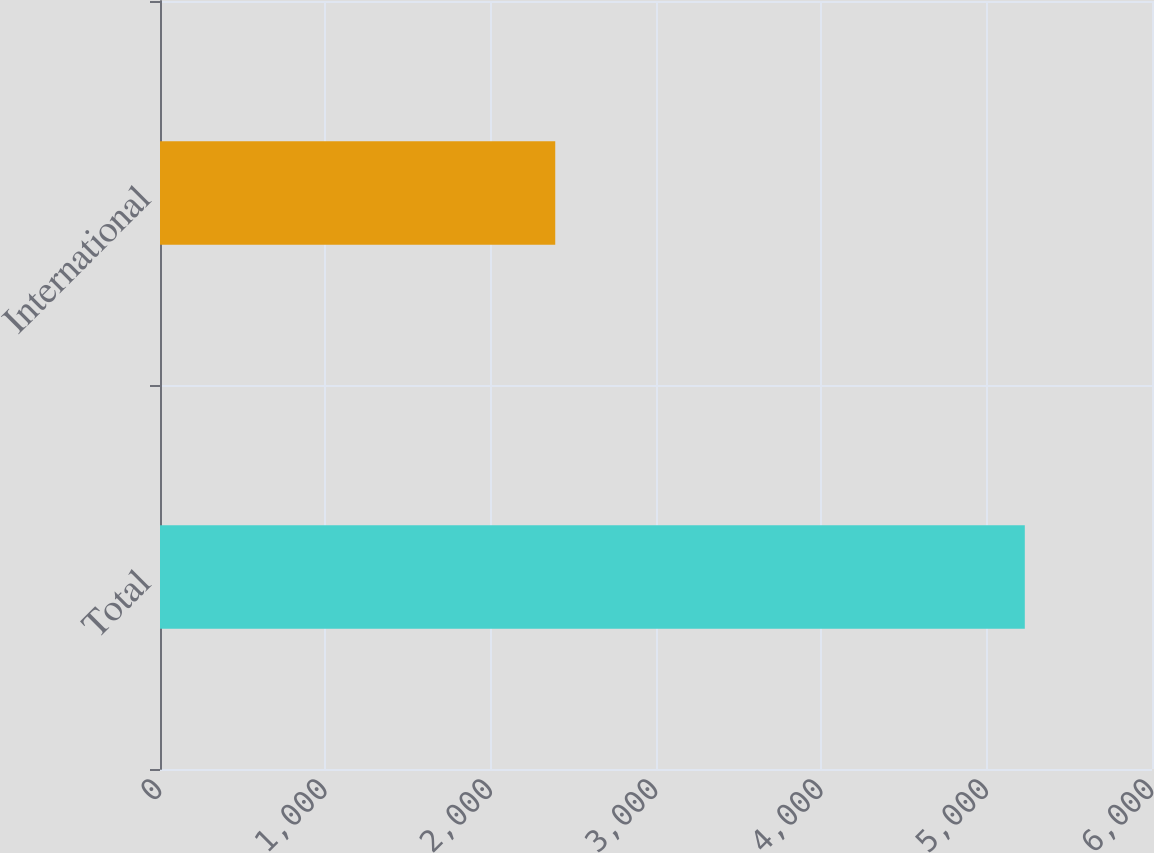Convert chart to OTSL. <chart><loc_0><loc_0><loc_500><loc_500><bar_chart><fcel>Total<fcel>International<nl><fcel>5230.6<fcel>2390.6<nl></chart> 